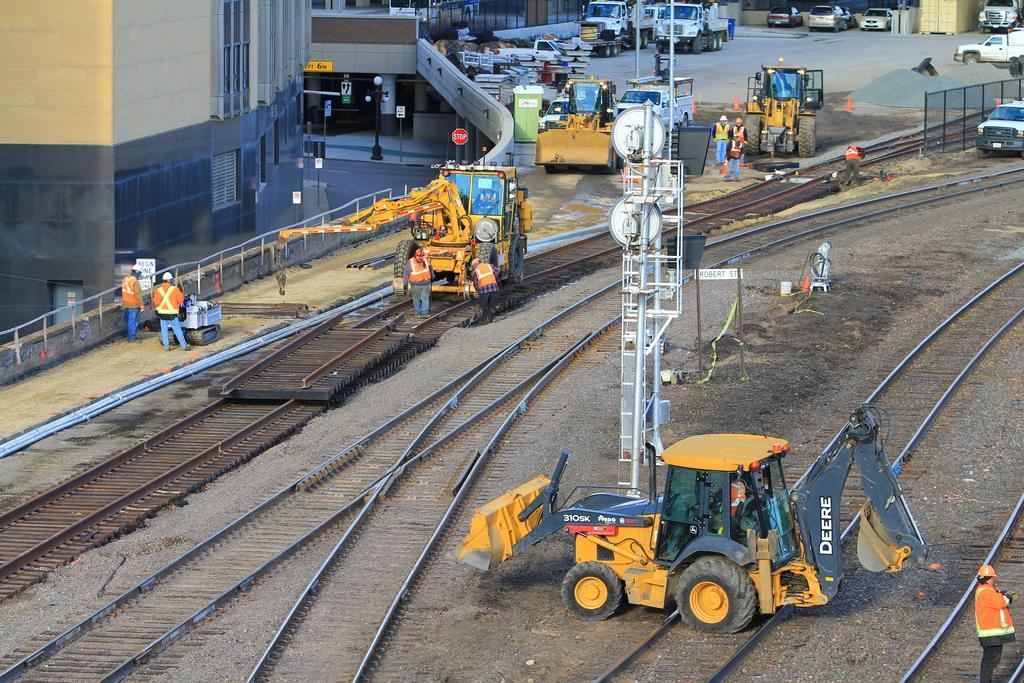Could you give a brief overview of what you see in this image? In this image we can see railway tracks, recliners. In the background of the image there are vehicles. There is a building. There are people. In the center of the image there is a tower. There are safety cones. 